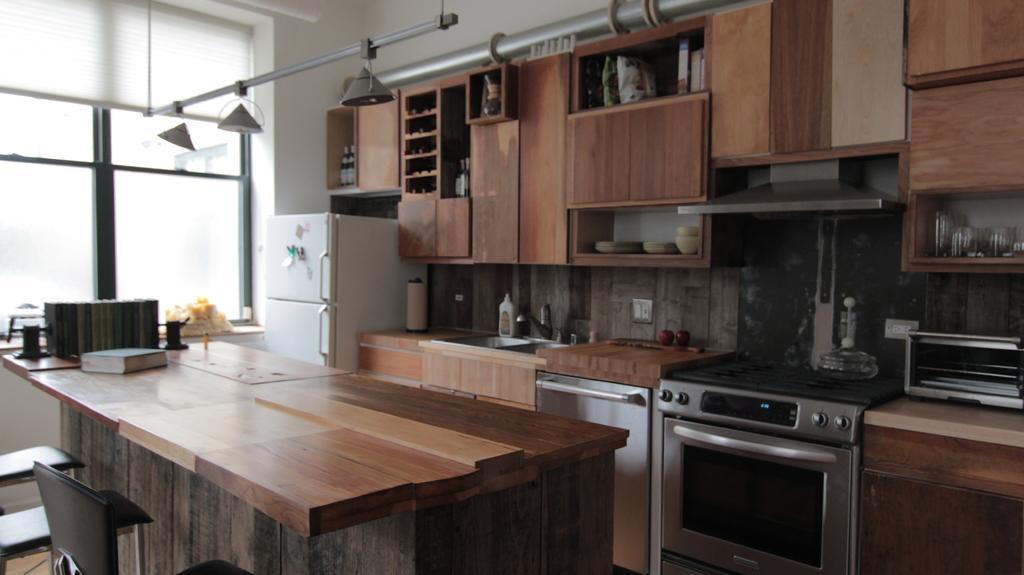Describe this image in one or two sentences. This image is taken inside the room. There is lots of furniture in this room. In the middle of the image there is a table which is made of wood and there are empty chairs. In the background there is a wall with window and window blind. There are many cupboards and shelves with few things in it. In the right side of the image there is an oven. 